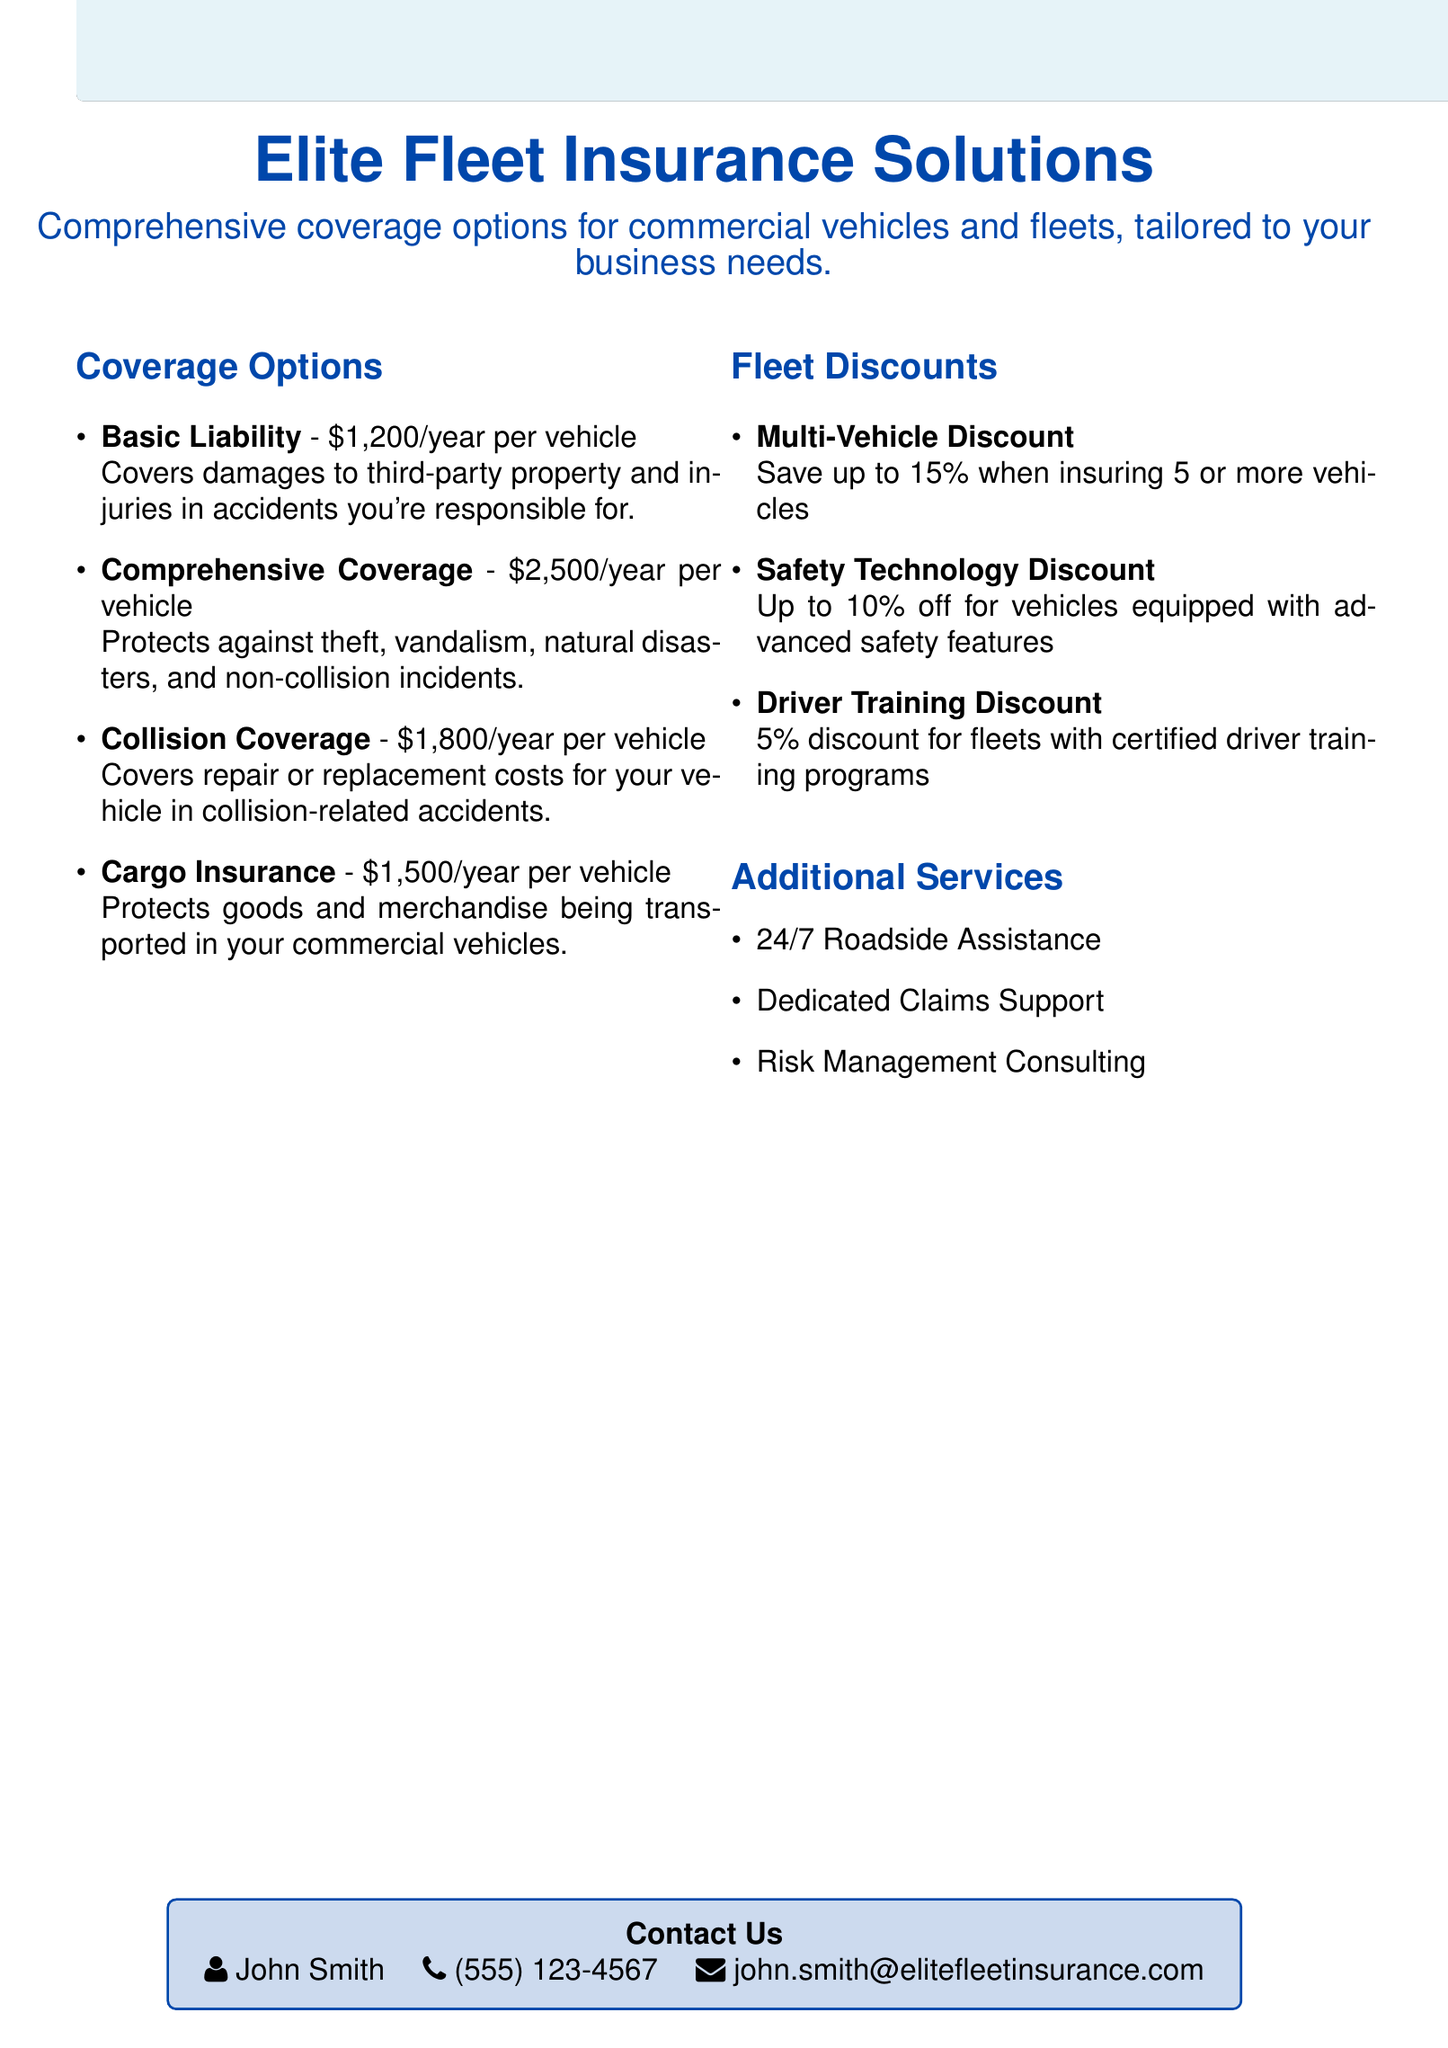what is the coverage option that protects against theft? The document states that Comprehensive Coverage protects against theft, vandalism, natural disasters, and non-collision incidents.
Answer: Comprehensive Coverage how much is the Basic Liability coverage per vehicle? The document specifies that Basic Liability coverage costs $1,200 per year for each vehicle.
Answer: $1,200/year what discount can be received for multiple vehicles? The text mentions a Multi-Vehicle Discount that allows saving when insuring 5 or more vehicles.
Answer: up to 15% who is the contact person listed in the document? The document provides the name of the contact person as John Smith.
Answer: John Smith what service is available 24/7? The document lists 24/7 Roadside Assistance as an additional service available at all times.
Answer: Roadside Assistance which discount is available for using advanced safety features? The document states that vehicles equipped with advanced safety features can receive a discount.
Answer: Safety Technology Discount how much does Cargo Insurance cost annually? The document mentions that Cargo Insurance costs $1,500 per year per vehicle.
Answer: $1,500/year what support does the document mention for claims? It specifies that there is Dedicated Claims Support available.
Answer: Dedicated Claims Support what is the pricing tier for Collision Coverage? The document states that Collision Coverage is $1,800 per year per vehicle.
Answer: $1,800/year 